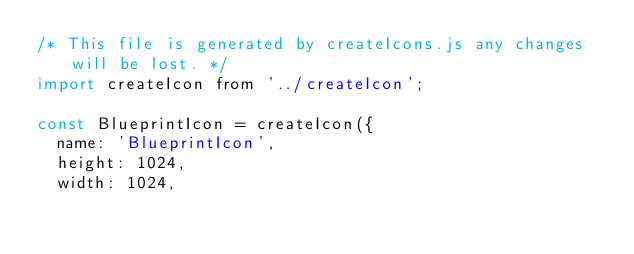<code> <loc_0><loc_0><loc_500><loc_500><_JavaScript_>/* This file is generated by createIcons.js any changes will be lost. */
import createIcon from '../createIcon';

const BlueprintIcon = createIcon({
  name: 'BlueprintIcon',
  height: 1024,
  width: 1024,</code> 